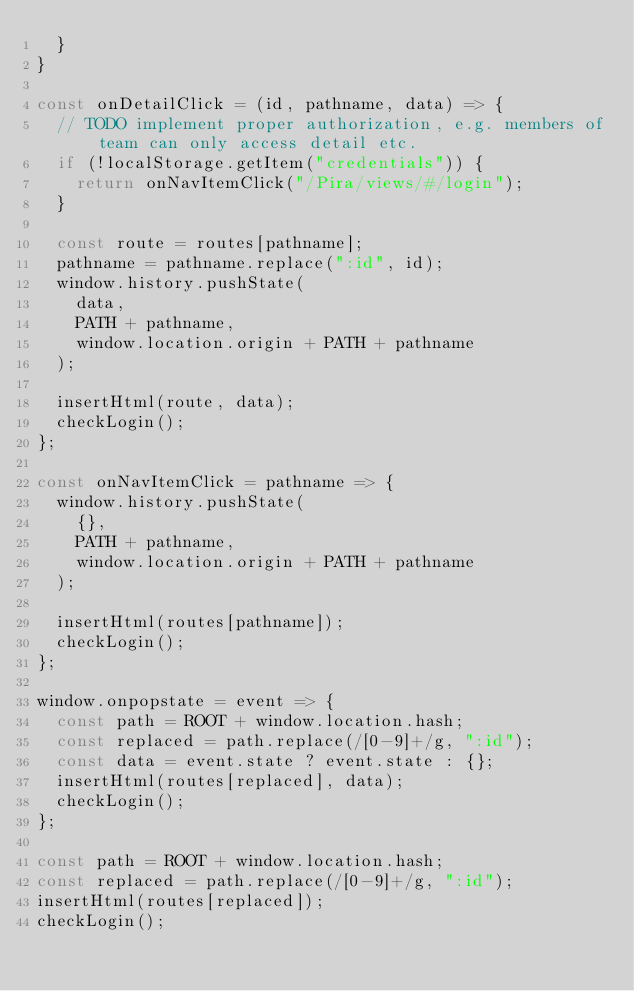<code> <loc_0><loc_0><loc_500><loc_500><_JavaScript_>  }
}

const onDetailClick = (id, pathname, data) => {
  // TODO implement proper authorization, e.g. members of team can only access detail etc.
  if (!localStorage.getItem("credentials")) {
    return onNavItemClick("/Pira/views/#/login");
  }

  const route = routes[pathname];
  pathname = pathname.replace(":id", id);
  window.history.pushState(
    data,
    PATH + pathname,
    window.location.origin + PATH + pathname
  );

  insertHtml(route, data);
  checkLogin();
};

const onNavItemClick = pathname => {
  window.history.pushState(
    {},
    PATH + pathname,
    window.location.origin + PATH + pathname
  );

  insertHtml(routes[pathname]);
  checkLogin();
};

window.onpopstate = event => {
  const path = ROOT + window.location.hash;
  const replaced = path.replace(/[0-9]+/g, ":id");
  const data = event.state ? event.state : {};
  insertHtml(routes[replaced], data);
  checkLogin();
};

const path = ROOT + window.location.hash;
const replaced = path.replace(/[0-9]+/g, ":id");
insertHtml(routes[replaced]);
checkLogin();
</code> 